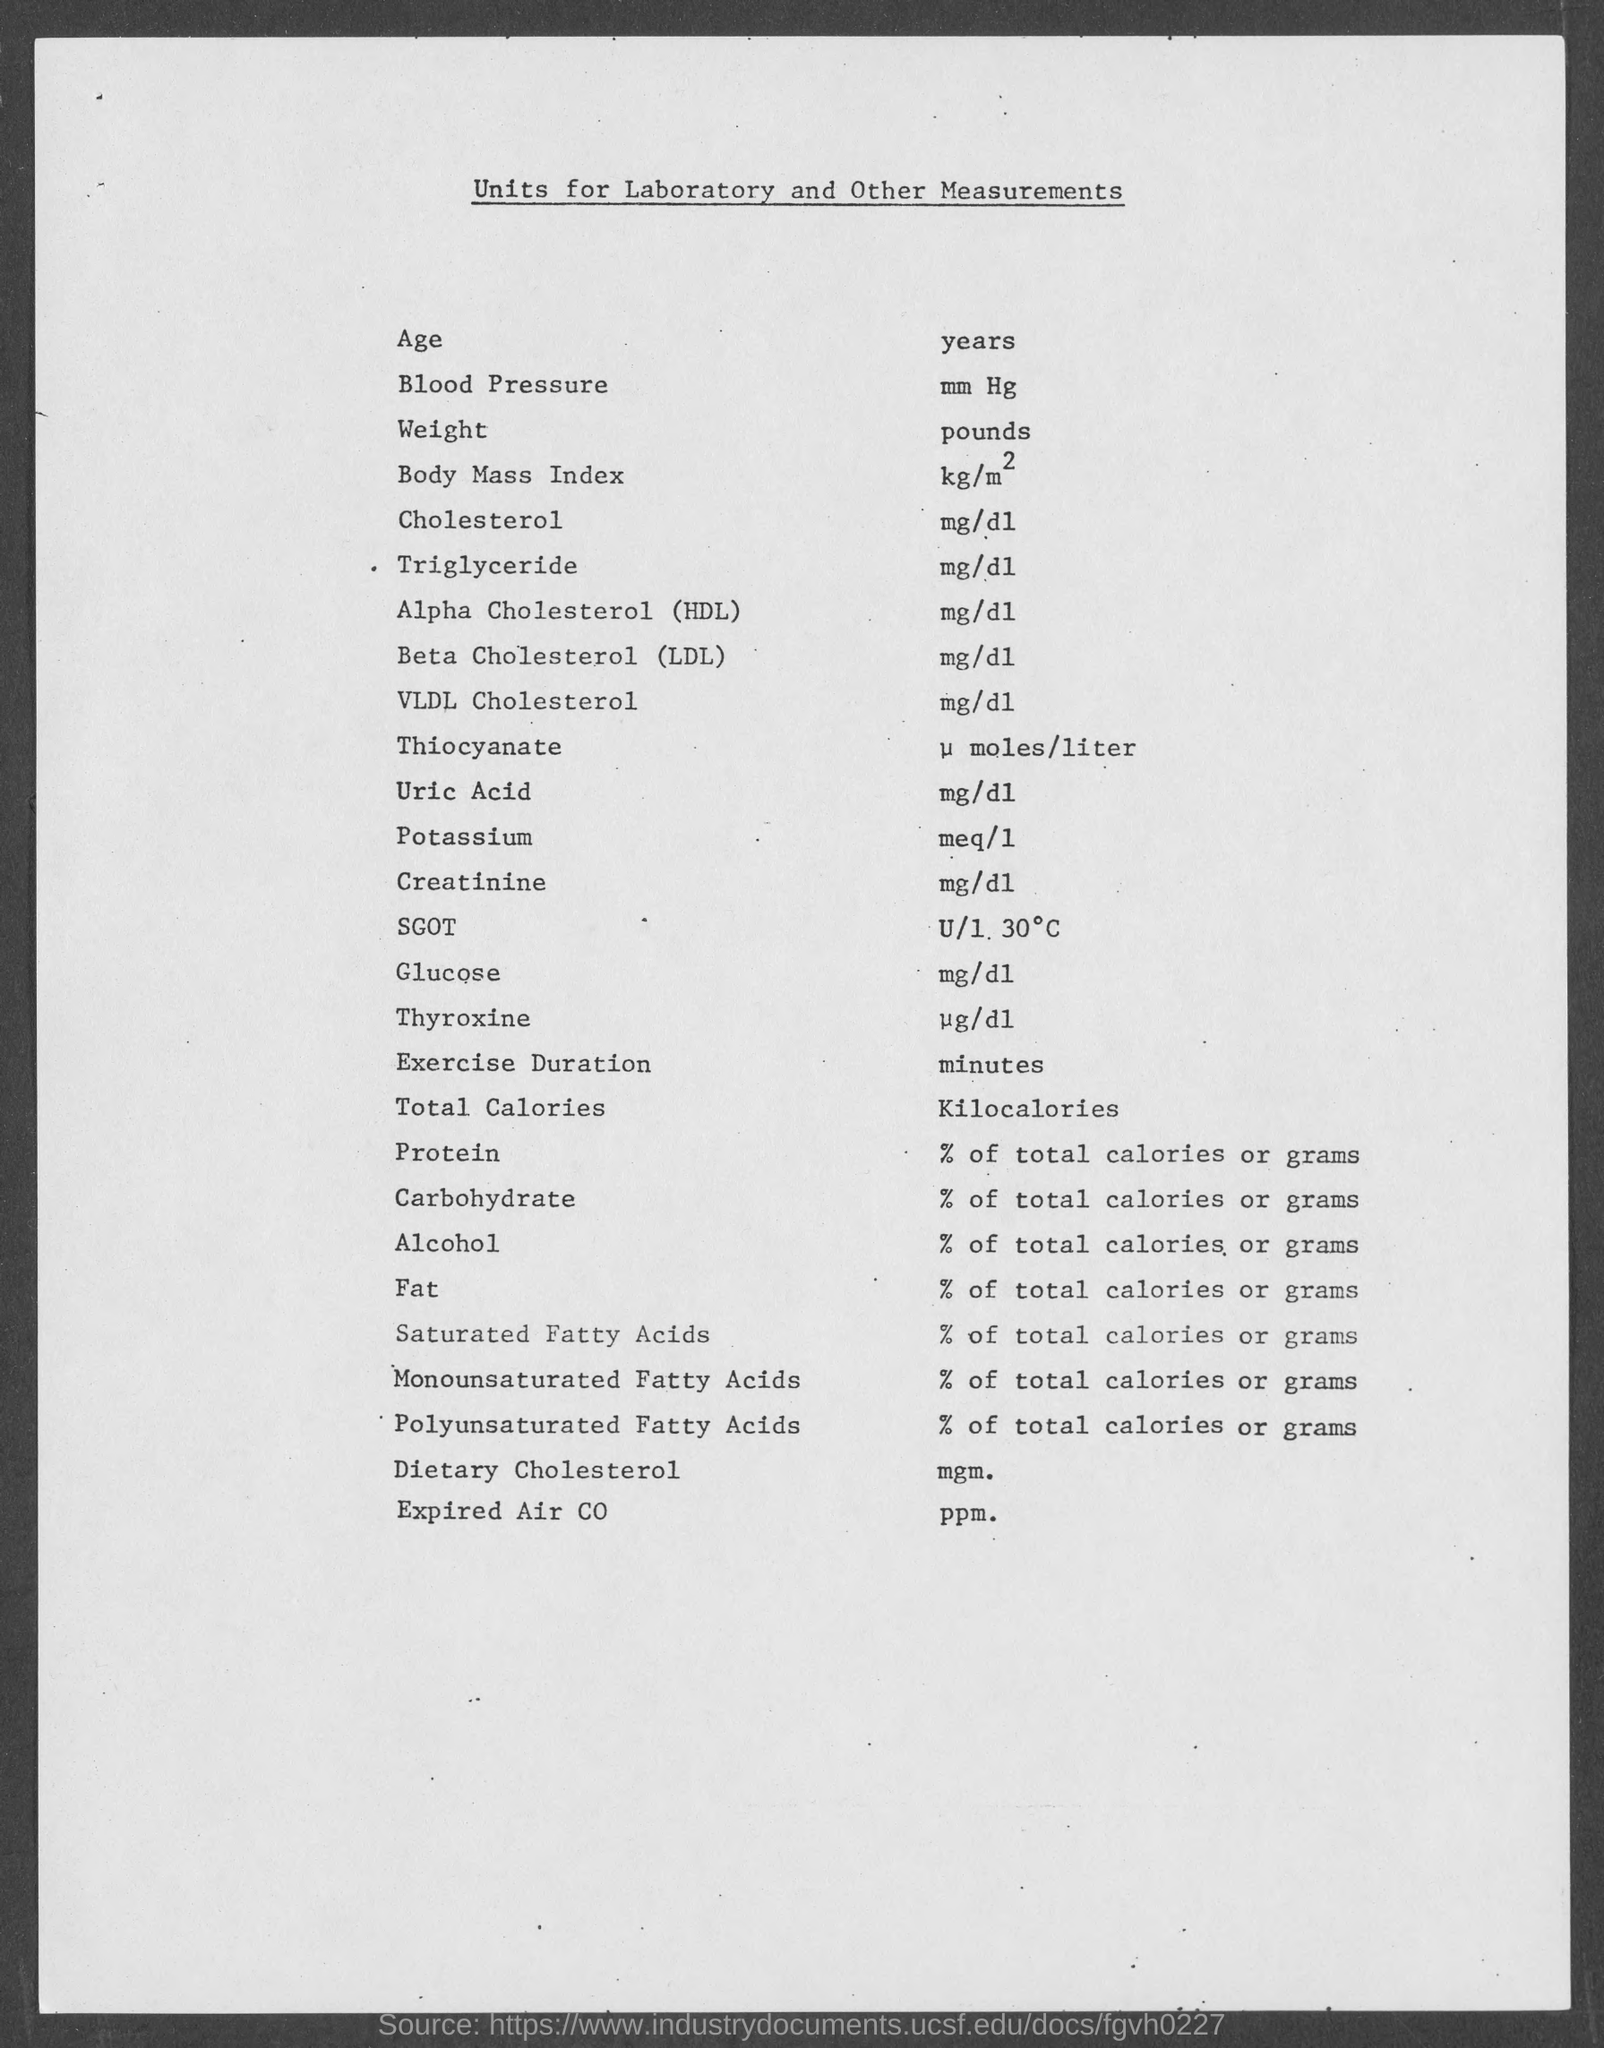What is the title of this document?
Give a very brief answer. Units for Laboratory and Other Measurements. What is the unit of Age given in the document?
Give a very brief answer. Years. What is the measurement unit for blood pressure?
Your answer should be very brief. Mm hg. What is the unit of measurement for protein?
Provide a short and direct response. % of total calories or grams. Which quantity is measured in pounds as per the document?
Your answer should be compact. Weight. What is the unit of measurement for Glucose?
Your answer should be compact. Mg/dl. What is the unit of measurement for Carbohydrates?
Provide a succinct answer. % of total calories or grams. 